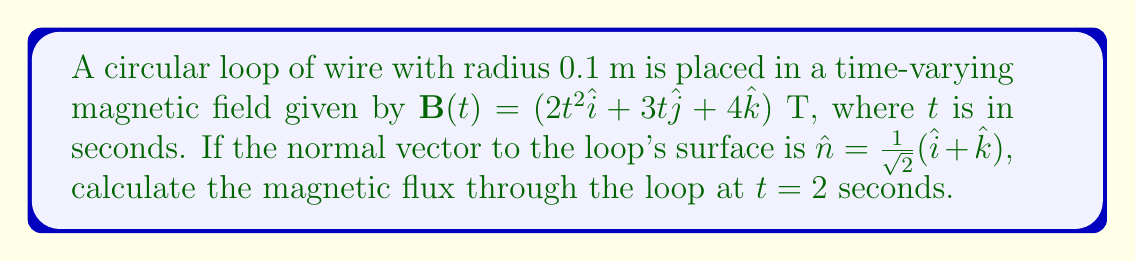Can you answer this question? To solve this problem, we'll follow these steps:

1) The magnetic flux $\Phi_B$ through a surface is given by:

   $$\Phi_B = \int \mathbf{B} \cdot d\mathbf{A}$$

   For a uniform field over a flat surface, this simplifies to:

   $$\Phi_B = \mathbf{B} \cdot \mathbf{A}$$

2) The area vector $\mathbf{A}$ is given by $A\hat{n}$, where $A$ is the area of the loop:

   $$A = \pi r^2 = \pi (0.1)^2 = 0.01\pi \text{ m}^2$$

3) At $t = 2$ seconds, the magnetic field is:

   $$\mathbf{B}(2) = (8\hat{i} + 6\hat{j} + 4\hat{k}) \text{ T}$$

4) Now we can calculate the dot product:

   $$\begin{align}
   \Phi_B &= (8\hat{i} + 6\hat{j} + 4\hat{k}) \cdot (0.01\pi)(\frac{1}{\sqrt{2}}(\hat{i} + \hat{k})) \\
   &= 0.01\pi (\frac{1}{\sqrt{2}}(8 + 4)) \\
   &= \frac{12}{\sqrt{2}}(0.01\pi) \\
   &\approx 0.2659 \text{ Wb}
   \end{align}$$
Answer: $0.2659 \text{ Wb}$ 